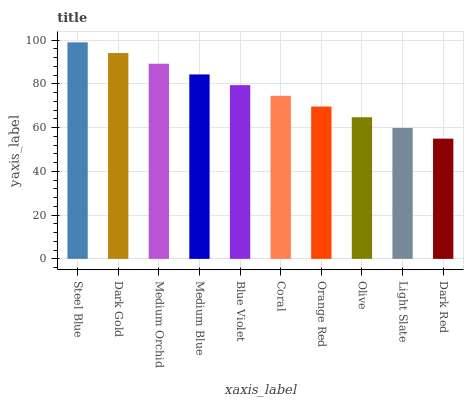Is Dark Red the minimum?
Answer yes or no. Yes. Is Steel Blue the maximum?
Answer yes or no. Yes. Is Dark Gold the minimum?
Answer yes or no. No. Is Dark Gold the maximum?
Answer yes or no. No. Is Steel Blue greater than Dark Gold?
Answer yes or no. Yes. Is Dark Gold less than Steel Blue?
Answer yes or no. Yes. Is Dark Gold greater than Steel Blue?
Answer yes or no. No. Is Steel Blue less than Dark Gold?
Answer yes or no. No. Is Blue Violet the high median?
Answer yes or no. Yes. Is Coral the low median?
Answer yes or no. Yes. Is Coral the high median?
Answer yes or no. No. Is Dark Gold the low median?
Answer yes or no. No. 